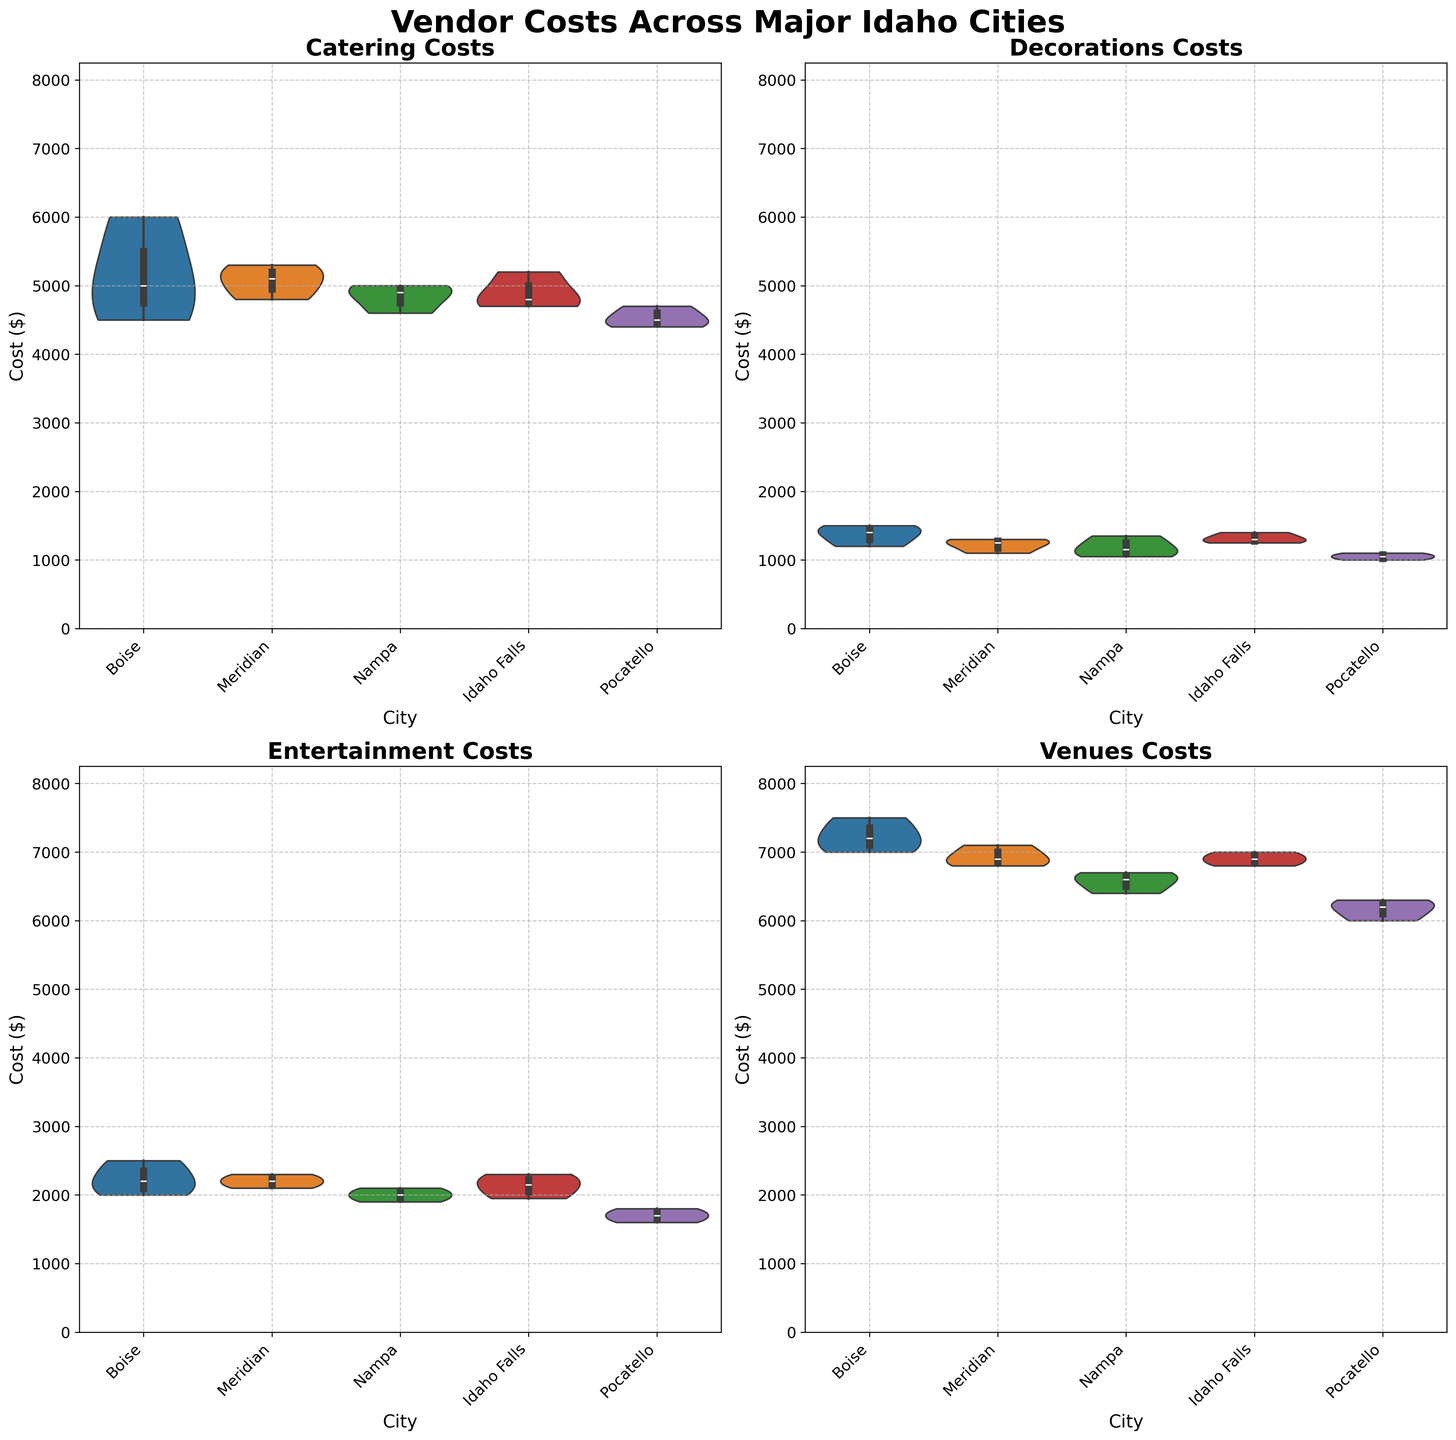What's the title of the figure? The title is located at the top center of the figure. It is usually written in a larger, bold font to make it stand out.
Answer: Vendor Costs Across Major Idaho Cities Which city has the highest median catering cost? The median is the middle value of the dataset. In a violin plot, the median is typically shown as a white dot or line within the plot. Boise's violin for catering costs is the tallest, indicating it has the highest median cost.
Answer: Boise What vendor type has the widest range of costs in Pocatello? The range can be observed by looking at the spread of the violin plot. For Pocatello, the "Venues" plot shows the widest spread from the lowest to highest value.
Answer: Venues Is the median decorations cost in Meridian higher than in Boise? We need to compare the middle value (median) of the decorations data in both cities. In the plot for Decorations, the white dot representing the median for Boise is higher than for Meridian.
Answer: No Which city has the lowest 25th percentile for entertainment costs? The 25th percentile is the lower part of the spread in the violin plot. For entertainment, Pocatello has the lowest edge of the violin plot compared to other cities.
Answer: Pocatello Compare the cost ranges for venues between Idaho Falls and Nampa. Which one is greater? The range is the spread from the lowest to highest part of the violin plot. Idaho Falls' venues plot is wider compared to that of Nampa's venues plot.
Answer: Idaho Falls Which vendor type consistently shows the highest cost across all cities? By observing the height and spread of each vendor type's violin plot, "Venues" plots have the highest costs in each city compared to other vendor types.
Answer: Venues Are the entertainment costs in Boise more variable than those in Nampa? Variability can be inferred from the width of the violin plot. Boise's plot for Entertainment shows a wider spread than Nampa's, indicating higher variability.
Answer: Yes What is the approximate highest cost for decorations in Boise? The highest cost in a violin plot is indicated by the top end of the plot. For decorations in Boise, the top of the plot is around $1500.
Answer: $1500 Which city has the closest median costs for catering and entertainment? To find the city where catering and entertainment medians are closest, compare the positions of the white dots for catering and entertainment. Meridian's medians for these vendor types are very close to each other.
Answer: Meridian 